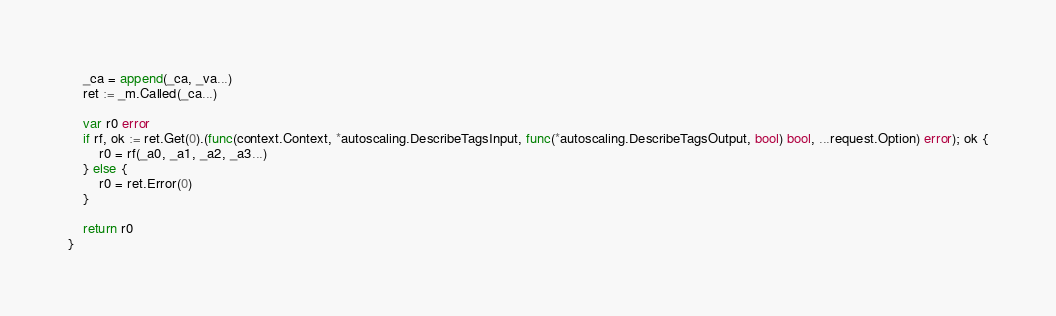<code> <loc_0><loc_0><loc_500><loc_500><_Go_>	_ca = append(_ca, _va...)
	ret := _m.Called(_ca...)

	var r0 error
	if rf, ok := ret.Get(0).(func(context.Context, *autoscaling.DescribeTagsInput, func(*autoscaling.DescribeTagsOutput, bool) bool, ...request.Option) error); ok {
		r0 = rf(_a0, _a1, _a2, _a3...)
	} else {
		r0 = ret.Error(0)
	}

	return r0
}
</code> 